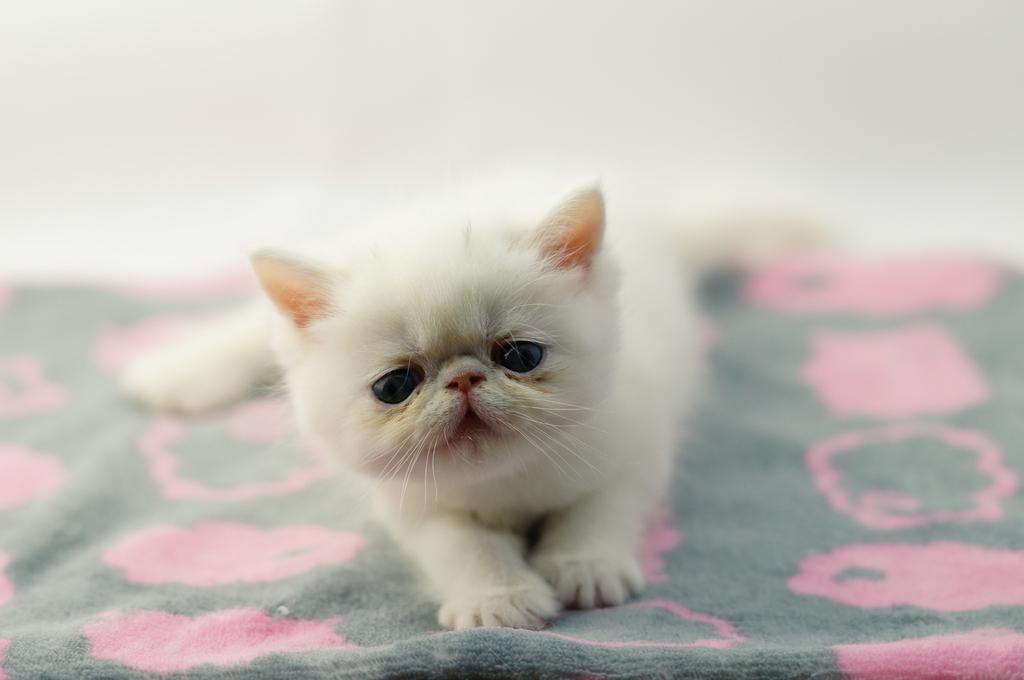Describe this image in one or two sentences. In this image I can see a white kitten on a bed sheet. The background is blurred. 